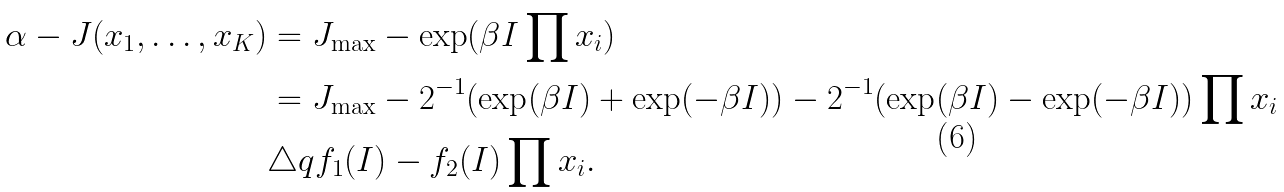<formula> <loc_0><loc_0><loc_500><loc_500>\alpha - J ( x _ { 1 } , \dots , x _ { K } ) & = J _ { \max } - \exp ( \beta I \prod x _ { i } ) \\ & = J _ { \max } - 2 ^ { - 1 } ( \exp ( \beta I ) + \exp ( - \beta I ) ) - 2 ^ { - 1 } ( \exp ( \beta I ) - \exp ( - \beta I ) ) \prod x _ { i } \\ & \triangle q f _ { 1 } ( I ) - f _ { 2 } ( I ) \prod x _ { i } .</formula> 